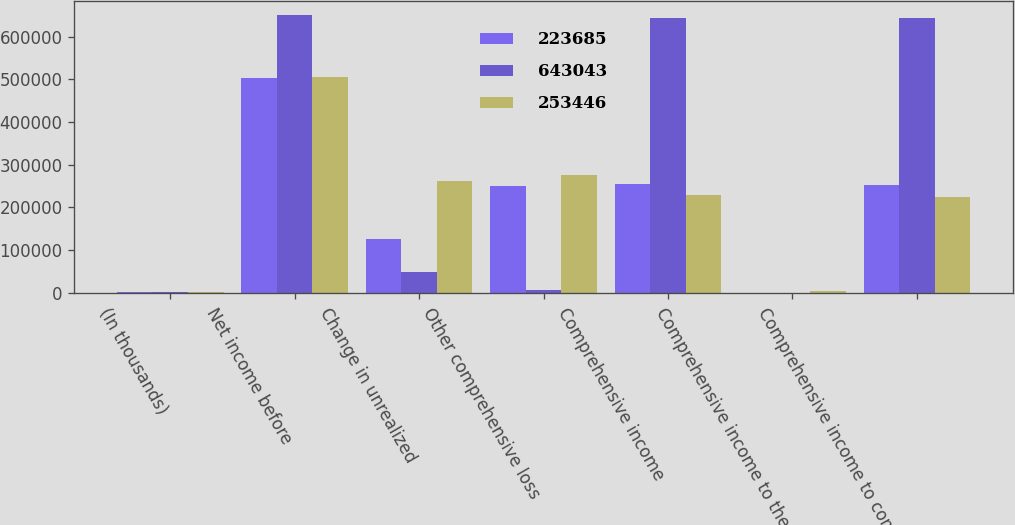<chart> <loc_0><loc_0><loc_500><loc_500><stacked_bar_chart><ecel><fcel>(In thousands)<fcel>Net income before<fcel>Change in unrealized<fcel>Other comprehensive loss<fcel>Comprehensive income<fcel>Comprehensive income to the<fcel>Comprehensive income to common<nl><fcel>223685<fcel>2015<fcel>504107<fcel>125542<fcel>250286<fcel>253821<fcel>375<fcel>253446<nl><fcel>643043<fcel>2014<fcel>649603<fcel>49666<fcel>5808<fcel>643795<fcel>752<fcel>643043<nl><fcel>253446<fcel>2013<fcel>505301<fcel>261064<fcel>276212<fcel>229089<fcel>5404<fcel>223685<nl></chart> 